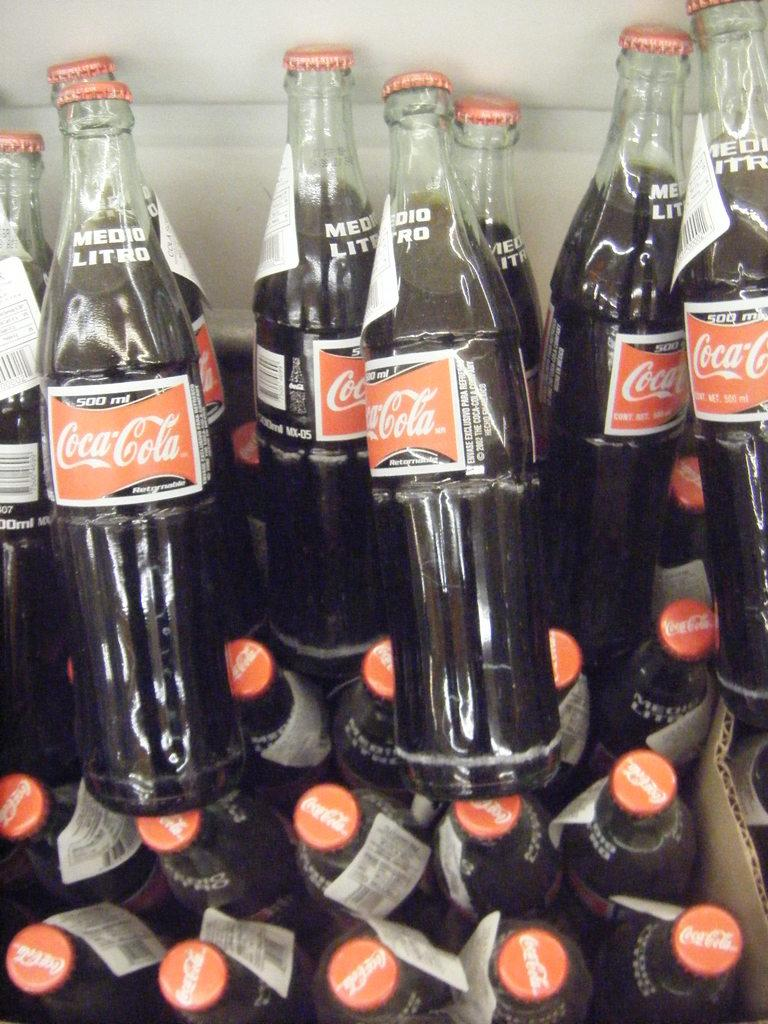<image>
Offer a succinct explanation of the picture presented. Glass bottles of Coca-Cola with barc code labels. 